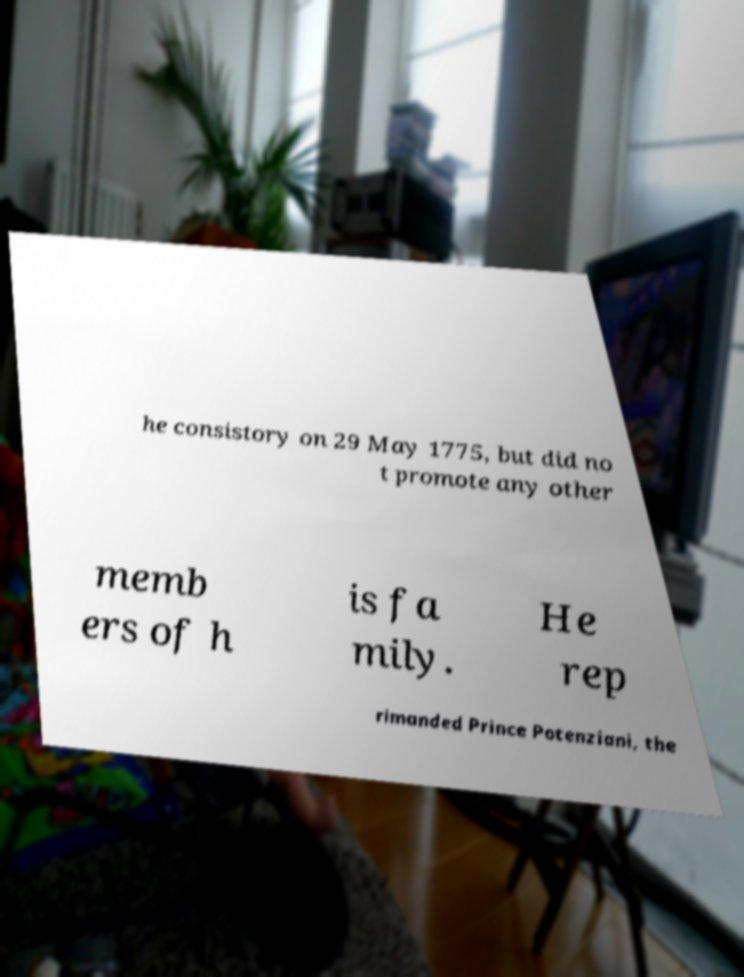Can you read and provide the text displayed in the image?This photo seems to have some interesting text. Can you extract and type it out for me? he consistory on 29 May 1775, but did no t promote any other memb ers of h is fa mily. He rep rimanded Prince Potenziani, the 